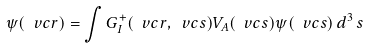Convert formula to latex. <formula><loc_0><loc_0><loc_500><loc_500>\psi ( \ v c r ) = \int G _ { I } ^ { + } ( \ v c r , \ v c s ) V _ { A } ( \ v c s ) \psi ( \ v c s ) \, d ^ { 3 } \, s \,</formula> 